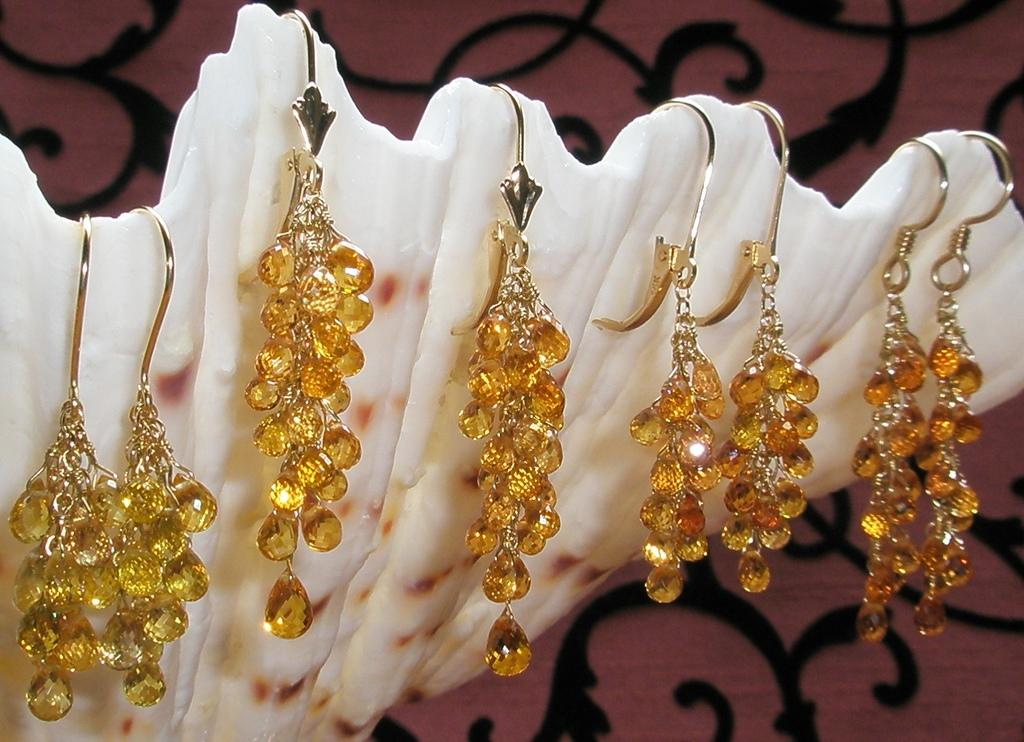What is the main subject in the center of the image? There are hanging items on a board in the center of the image. Can you describe the hanging items? Unfortunately, the provided facts do not give any details about the hanging items. What can be seen in the background of the image? There is a grille visible in the background of the image. What type of oatmeal is being served on the page in the image? There is no page or oatmeal present in the image. How does the snow affect the visibility of the hanging items in the image? There is no snow present in the image, so it does not affect the visibility of the hanging items. 